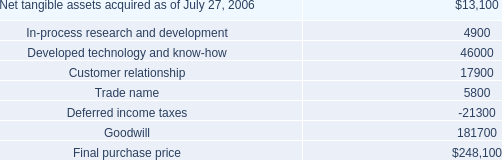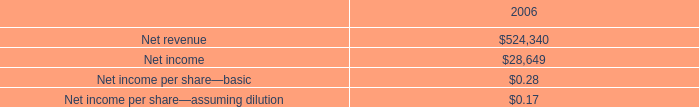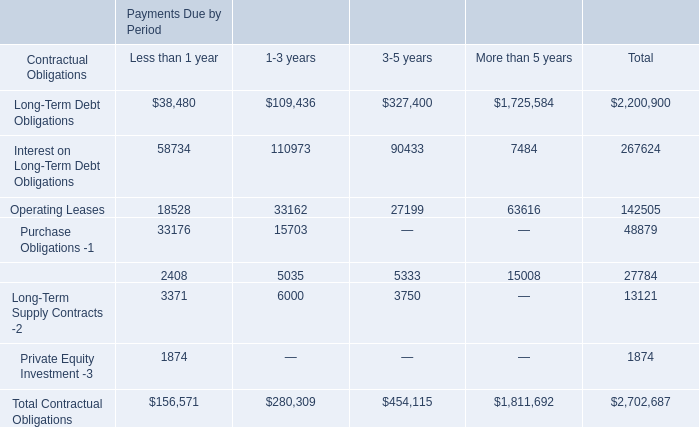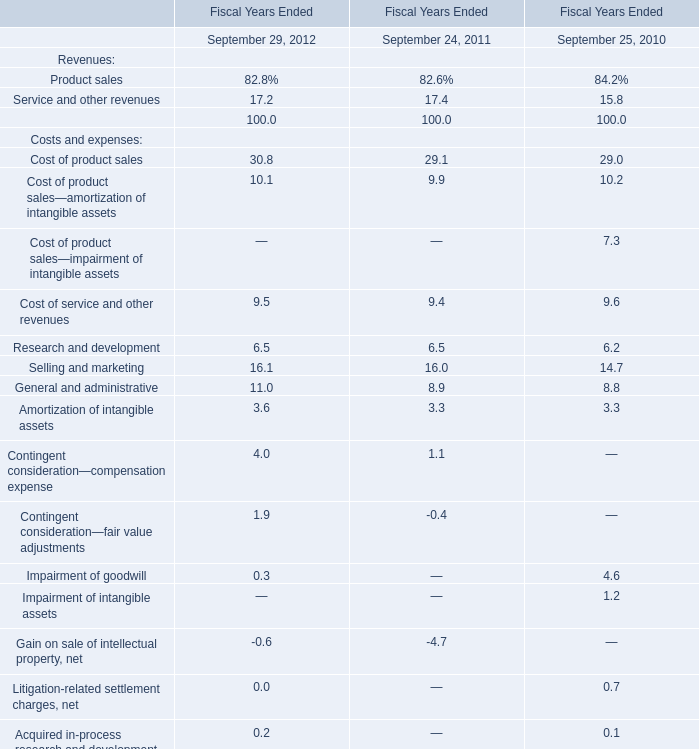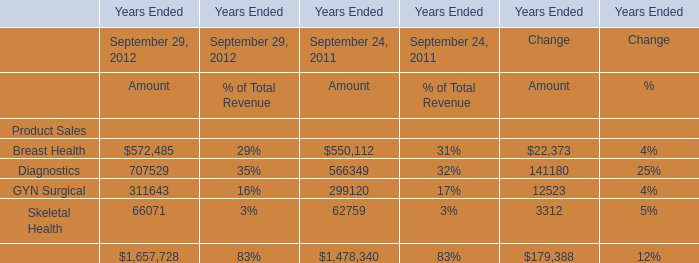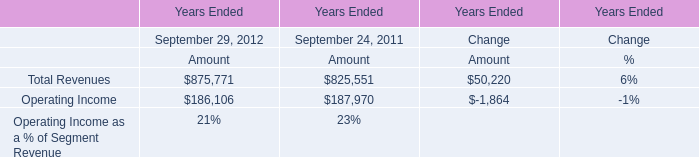what would pro forma net income have been if the charge for purchased research and development had been expensed? 
Computations: (28649 - 15100)
Answer: 13549.0. 